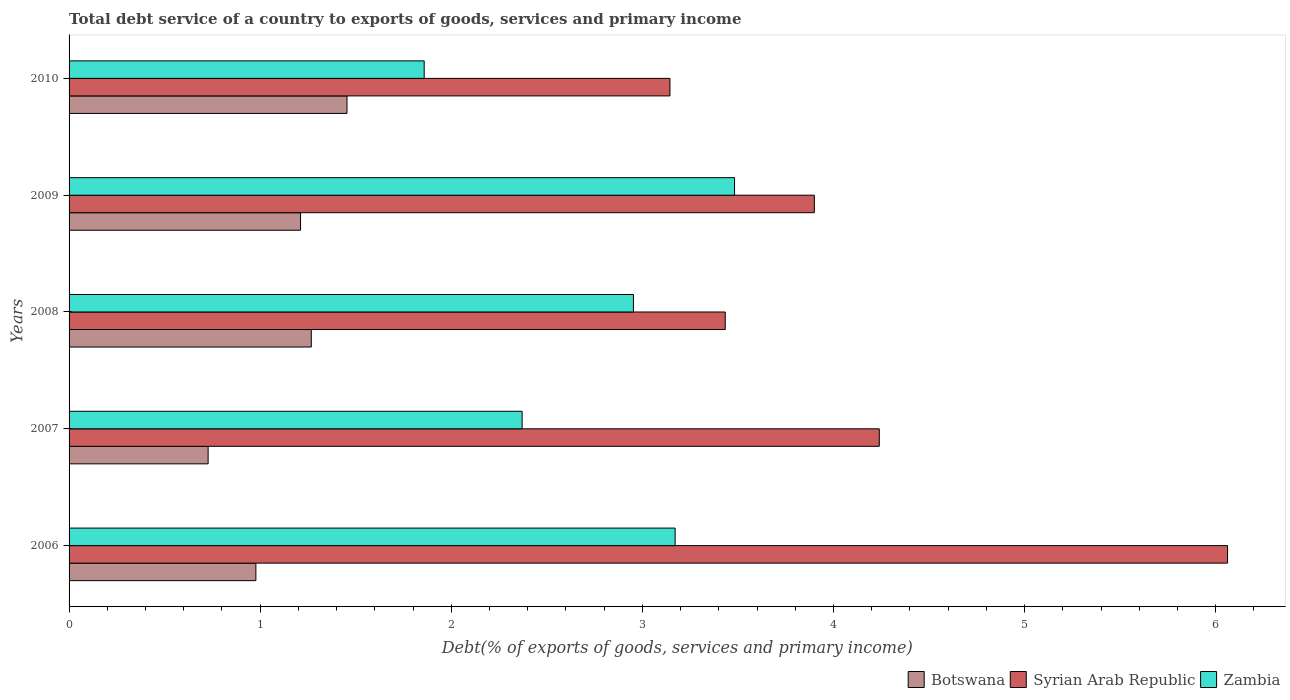How many groups of bars are there?
Your answer should be compact. 5. How many bars are there on the 3rd tick from the top?
Provide a succinct answer. 3. What is the label of the 4th group of bars from the top?
Ensure brevity in your answer.  2007. In how many cases, is the number of bars for a given year not equal to the number of legend labels?
Keep it short and to the point. 0. What is the total debt service in Zambia in 2006?
Make the answer very short. 3.17. Across all years, what is the maximum total debt service in Syrian Arab Republic?
Your answer should be very brief. 6.06. Across all years, what is the minimum total debt service in Botswana?
Keep it short and to the point. 0.73. In which year was the total debt service in Botswana maximum?
Give a very brief answer. 2010. What is the total total debt service in Zambia in the graph?
Provide a short and direct response. 13.84. What is the difference between the total debt service in Syrian Arab Republic in 2009 and that in 2010?
Offer a terse response. 0.76. What is the difference between the total debt service in Botswana in 2010 and the total debt service in Zambia in 2008?
Ensure brevity in your answer.  -1.5. What is the average total debt service in Botswana per year?
Your answer should be very brief. 1.13. In the year 2008, what is the difference between the total debt service in Syrian Arab Republic and total debt service in Zambia?
Make the answer very short. 0.48. What is the ratio of the total debt service in Syrian Arab Republic in 2008 to that in 2010?
Your response must be concise. 1.09. What is the difference between the highest and the second highest total debt service in Botswana?
Keep it short and to the point. 0.19. What is the difference between the highest and the lowest total debt service in Syrian Arab Republic?
Your response must be concise. 2.92. Is the sum of the total debt service in Syrian Arab Republic in 2008 and 2009 greater than the maximum total debt service in Zambia across all years?
Keep it short and to the point. Yes. What does the 3rd bar from the top in 2010 represents?
Your answer should be compact. Botswana. What does the 3rd bar from the bottom in 2008 represents?
Give a very brief answer. Zambia. How many bars are there?
Give a very brief answer. 15. How many years are there in the graph?
Provide a succinct answer. 5. Does the graph contain any zero values?
Provide a succinct answer. No. Where does the legend appear in the graph?
Make the answer very short. Bottom right. How are the legend labels stacked?
Make the answer very short. Horizontal. What is the title of the graph?
Provide a succinct answer. Total debt service of a country to exports of goods, services and primary income. What is the label or title of the X-axis?
Provide a short and direct response. Debt(% of exports of goods, services and primary income). What is the label or title of the Y-axis?
Ensure brevity in your answer.  Years. What is the Debt(% of exports of goods, services and primary income) of Botswana in 2006?
Keep it short and to the point. 0.98. What is the Debt(% of exports of goods, services and primary income) of Syrian Arab Republic in 2006?
Make the answer very short. 6.06. What is the Debt(% of exports of goods, services and primary income) of Zambia in 2006?
Provide a succinct answer. 3.17. What is the Debt(% of exports of goods, services and primary income) in Botswana in 2007?
Provide a short and direct response. 0.73. What is the Debt(% of exports of goods, services and primary income) in Syrian Arab Republic in 2007?
Your answer should be very brief. 4.24. What is the Debt(% of exports of goods, services and primary income) of Zambia in 2007?
Ensure brevity in your answer.  2.37. What is the Debt(% of exports of goods, services and primary income) in Botswana in 2008?
Offer a very short reply. 1.27. What is the Debt(% of exports of goods, services and primary income) in Syrian Arab Republic in 2008?
Provide a short and direct response. 3.43. What is the Debt(% of exports of goods, services and primary income) in Zambia in 2008?
Your response must be concise. 2.95. What is the Debt(% of exports of goods, services and primary income) of Botswana in 2009?
Your response must be concise. 1.21. What is the Debt(% of exports of goods, services and primary income) in Syrian Arab Republic in 2009?
Give a very brief answer. 3.9. What is the Debt(% of exports of goods, services and primary income) of Zambia in 2009?
Keep it short and to the point. 3.48. What is the Debt(% of exports of goods, services and primary income) of Botswana in 2010?
Your answer should be compact. 1.45. What is the Debt(% of exports of goods, services and primary income) in Syrian Arab Republic in 2010?
Provide a succinct answer. 3.14. What is the Debt(% of exports of goods, services and primary income) of Zambia in 2010?
Provide a short and direct response. 1.86. Across all years, what is the maximum Debt(% of exports of goods, services and primary income) of Botswana?
Your response must be concise. 1.45. Across all years, what is the maximum Debt(% of exports of goods, services and primary income) in Syrian Arab Republic?
Give a very brief answer. 6.06. Across all years, what is the maximum Debt(% of exports of goods, services and primary income) of Zambia?
Offer a very short reply. 3.48. Across all years, what is the minimum Debt(% of exports of goods, services and primary income) of Botswana?
Provide a succinct answer. 0.73. Across all years, what is the minimum Debt(% of exports of goods, services and primary income) of Syrian Arab Republic?
Provide a short and direct response. 3.14. Across all years, what is the minimum Debt(% of exports of goods, services and primary income) of Zambia?
Provide a succinct answer. 1.86. What is the total Debt(% of exports of goods, services and primary income) of Botswana in the graph?
Keep it short and to the point. 5.64. What is the total Debt(% of exports of goods, services and primary income) of Syrian Arab Republic in the graph?
Your answer should be very brief. 20.78. What is the total Debt(% of exports of goods, services and primary income) in Zambia in the graph?
Offer a terse response. 13.84. What is the difference between the Debt(% of exports of goods, services and primary income) of Botswana in 2006 and that in 2007?
Provide a short and direct response. 0.25. What is the difference between the Debt(% of exports of goods, services and primary income) of Syrian Arab Republic in 2006 and that in 2007?
Offer a very short reply. 1.82. What is the difference between the Debt(% of exports of goods, services and primary income) of Zambia in 2006 and that in 2007?
Your response must be concise. 0.8. What is the difference between the Debt(% of exports of goods, services and primary income) in Botswana in 2006 and that in 2008?
Offer a terse response. -0.29. What is the difference between the Debt(% of exports of goods, services and primary income) of Syrian Arab Republic in 2006 and that in 2008?
Give a very brief answer. 2.63. What is the difference between the Debt(% of exports of goods, services and primary income) of Zambia in 2006 and that in 2008?
Keep it short and to the point. 0.22. What is the difference between the Debt(% of exports of goods, services and primary income) in Botswana in 2006 and that in 2009?
Provide a succinct answer. -0.23. What is the difference between the Debt(% of exports of goods, services and primary income) of Syrian Arab Republic in 2006 and that in 2009?
Offer a very short reply. 2.16. What is the difference between the Debt(% of exports of goods, services and primary income) of Zambia in 2006 and that in 2009?
Provide a succinct answer. -0.31. What is the difference between the Debt(% of exports of goods, services and primary income) in Botswana in 2006 and that in 2010?
Make the answer very short. -0.48. What is the difference between the Debt(% of exports of goods, services and primary income) of Syrian Arab Republic in 2006 and that in 2010?
Make the answer very short. 2.92. What is the difference between the Debt(% of exports of goods, services and primary income) of Zambia in 2006 and that in 2010?
Make the answer very short. 1.31. What is the difference between the Debt(% of exports of goods, services and primary income) of Botswana in 2007 and that in 2008?
Give a very brief answer. -0.54. What is the difference between the Debt(% of exports of goods, services and primary income) in Syrian Arab Republic in 2007 and that in 2008?
Offer a terse response. 0.81. What is the difference between the Debt(% of exports of goods, services and primary income) of Zambia in 2007 and that in 2008?
Keep it short and to the point. -0.58. What is the difference between the Debt(% of exports of goods, services and primary income) in Botswana in 2007 and that in 2009?
Your response must be concise. -0.48. What is the difference between the Debt(% of exports of goods, services and primary income) of Syrian Arab Republic in 2007 and that in 2009?
Provide a short and direct response. 0.34. What is the difference between the Debt(% of exports of goods, services and primary income) in Zambia in 2007 and that in 2009?
Give a very brief answer. -1.11. What is the difference between the Debt(% of exports of goods, services and primary income) in Botswana in 2007 and that in 2010?
Provide a short and direct response. -0.73. What is the difference between the Debt(% of exports of goods, services and primary income) in Syrian Arab Republic in 2007 and that in 2010?
Make the answer very short. 1.1. What is the difference between the Debt(% of exports of goods, services and primary income) in Zambia in 2007 and that in 2010?
Your response must be concise. 0.51. What is the difference between the Debt(% of exports of goods, services and primary income) in Botswana in 2008 and that in 2009?
Provide a short and direct response. 0.06. What is the difference between the Debt(% of exports of goods, services and primary income) in Syrian Arab Republic in 2008 and that in 2009?
Make the answer very short. -0.47. What is the difference between the Debt(% of exports of goods, services and primary income) in Zambia in 2008 and that in 2009?
Provide a short and direct response. -0.53. What is the difference between the Debt(% of exports of goods, services and primary income) in Botswana in 2008 and that in 2010?
Provide a succinct answer. -0.19. What is the difference between the Debt(% of exports of goods, services and primary income) in Syrian Arab Republic in 2008 and that in 2010?
Offer a terse response. 0.29. What is the difference between the Debt(% of exports of goods, services and primary income) in Zambia in 2008 and that in 2010?
Provide a short and direct response. 1.09. What is the difference between the Debt(% of exports of goods, services and primary income) of Botswana in 2009 and that in 2010?
Ensure brevity in your answer.  -0.24. What is the difference between the Debt(% of exports of goods, services and primary income) in Syrian Arab Republic in 2009 and that in 2010?
Keep it short and to the point. 0.76. What is the difference between the Debt(% of exports of goods, services and primary income) of Zambia in 2009 and that in 2010?
Your answer should be very brief. 1.62. What is the difference between the Debt(% of exports of goods, services and primary income) of Botswana in 2006 and the Debt(% of exports of goods, services and primary income) of Syrian Arab Republic in 2007?
Make the answer very short. -3.26. What is the difference between the Debt(% of exports of goods, services and primary income) in Botswana in 2006 and the Debt(% of exports of goods, services and primary income) in Zambia in 2007?
Offer a terse response. -1.39. What is the difference between the Debt(% of exports of goods, services and primary income) in Syrian Arab Republic in 2006 and the Debt(% of exports of goods, services and primary income) in Zambia in 2007?
Your answer should be compact. 3.69. What is the difference between the Debt(% of exports of goods, services and primary income) in Botswana in 2006 and the Debt(% of exports of goods, services and primary income) in Syrian Arab Republic in 2008?
Provide a short and direct response. -2.46. What is the difference between the Debt(% of exports of goods, services and primary income) in Botswana in 2006 and the Debt(% of exports of goods, services and primary income) in Zambia in 2008?
Make the answer very short. -1.98. What is the difference between the Debt(% of exports of goods, services and primary income) in Syrian Arab Republic in 2006 and the Debt(% of exports of goods, services and primary income) in Zambia in 2008?
Provide a succinct answer. 3.11. What is the difference between the Debt(% of exports of goods, services and primary income) in Botswana in 2006 and the Debt(% of exports of goods, services and primary income) in Syrian Arab Republic in 2009?
Your answer should be compact. -2.92. What is the difference between the Debt(% of exports of goods, services and primary income) in Botswana in 2006 and the Debt(% of exports of goods, services and primary income) in Zambia in 2009?
Provide a short and direct response. -2.5. What is the difference between the Debt(% of exports of goods, services and primary income) in Syrian Arab Republic in 2006 and the Debt(% of exports of goods, services and primary income) in Zambia in 2009?
Make the answer very short. 2.58. What is the difference between the Debt(% of exports of goods, services and primary income) of Botswana in 2006 and the Debt(% of exports of goods, services and primary income) of Syrian Arab Republic in 2010?
Your response must be concise. -2.17. What is the difference between the Debt(% of exports of goods, services and primary income) of Botswana in 2006 and the Debt(% of exports of goods, services and primary income) of Zambia in 2010?
Provide a short and direct response. -0.88. What is the difference between the Debt(% of exports of goods, services and primary income) in Syrian Arab Republic in 2006 and the Debt(% of exports of goods, services and primary income) in Zambia in 2010?
Your response must be concise. 4.2. What is the difference between the Debt(% of exports of goods, services and primary income) in Botswana in 2007 and the Debt(% of exports of goods, services and primary income) in Syrian Arab Republic in 2008?
Offer a very short reply. -2.71. What is the difference between the Debt(% of exports of goods, services and primary income) of Botswana in 2007 and the Debt(% of exports of goods, services and primary income) of Zambia in 2008?
Keep it short and to the point. -2.23. What is the difference between the Debt(% of exports of goods, services and primary income) in Syrian Arab Republic in 2007 and the Debt(% of exports of goods, services and primary income) in Zambia in 2008?
Make the answer very short. 1.29. What is the difference between the Debt(% of exports of goods, services and primary income) in Botswana in 2007 and the Debt(% of exports of goods, services and primary income) in Syrian Arab Republic in 2009?
Offer a very short reply. -3.17. What is the difference between the Debt(% of exports of goods, services and primary income) of Botswana in 2007 and the Debt(% of exports of goods, services and primary income) of Zambia in 2009?
Make the answer very short. -2.75. What is the difference between the Debt(% of exports of goods, services and primary income) in Syrian Arab Republic in 2007 and the Debt(% of exports of goods, services and primary income) in Zambia in 2009?
Provide a short and direct response. 0.76. What is the difference between the Debt(% of exports of goods, services and primary income) in Botswana in 2007 and the Debt(% of exports of goods, services and primary income) in Syrian Arab Republic in 2010?
Ensure brevity in your answer.  -2.42. What is the difference between the Debt(% of exports of goods, services and primary income) of Botswana in 2007 and the Debt(% of exports of goods, services and primary income) of Zambia in 2010?
Provide a short and direct response. -1.13. What is the difference between the Debt(% of exports of goods, services and primary income) of Syrian Arab Republic in 2007 and the Debt(% of exports of goods, services and primary income) of Zambia in 2010?
Provide a short and direct response. 2.38. What is the difference between the Debt(% of exports of goods, services and primary income) of Botswana in 2008 and the Debt(% of exports of goods, services and primary income) of Syrian Arab Republic in 2009?
Your answer should be very brief. -2.63. What is the difference between the Debt(% of exports of goods, services and primary income) of Botswana in 2008 and the Debt(% of exports of goods, services and primary income) of Zambia in 2009?
Provide a succinct answer. -2.21. What is the difference between the Debt(% of exports of goods, services and primary income) of Syrian Arab Republic in 2008 and the Debt(% of exports of goods, services and primary income) of Zambia in 2009?
Your answer should be compact. -0.05. What is the difference between the Debt(% of exports of goods, services and primary income) in Botswana in 2008 and the Debt(% of exports of goods, services and primary income) in Syrian Arab Republic in 2010?
Offer a terse response. -1.88. What is the difference between the Debt(% of exports of goods, services and primary income) of Botswana in 2008 and the Debt(% of exports of goods, services and primary income) of Zambia in 2010?
Your response must be concise. -0.59. What is the difference between the Debt(% of exports of goods, services and primary income) of Syrian Arab Republic in 2008 and the Debt(% of exports of goods, services and primary income) of Zambia in 2010?
Keep it short and to the point. 1.58. What is the difference between the Debt(% of exports of goods, services and primary income) of Botswana in 2009 and the Debt(% of exports of goods, services and primary income) of Syrian Arab Republic in 2010?
Make the answer very short. -1.93. What is the difference between the Debt(% of exports of goods, services and primary income) in Botswana in 2009 and the Debt(% of exports of goods, services and primary income) in Zambia in 2010?
Offer a very short reply. -0.65. What is the difference between the Debt(% of exports of goods, services and primary income) of Syrian Arab Republic in 2009 and the Debt(% of exports of goods, services and primary income) of Zambia in 2010?
Offer a terse response. 2.04. What is the average Debt(% of exports of goods, services and primary income) of Botswana per year?
Ensure brevity in your answer.  1.13. What is the average Debt(% of exports of goods, services and primary income) of Syrian Arab Republic per year?
Your answer should be very brief. 4.16. What is the average Debt(% of exports of goods, services and primary income) in Zambia per year?
Offer a terse response. 2.77. In the year 2006, what is the difference between the Debt(% of exports of goods, services and primary income) of Botswana and Debt(% of exports of goods, services and primary income) of Syrian Arab Republic?
Make the answer very short. -5.08. In the year 2006, what is the difference between the Debt(% of exports of goods, services and primary income) of Botswana and Debt(% of exports of goods, services and primary income) of Zambia?
Provide a short and direct response. -2.19. In the year 2006, what is the difference between the Debt(% of exports of goods, services and primary income) of Syrian Arab Republic and Debt(% of exports of goods, services and primary income) of Zambia?
Your answer should be very brief. 2.89. In the year 2007, what is the difference between the Debt(% of exports of goods, services and primary income) of Botswana and Debt(% of exports of goods, services and primary income) of Syrian Arab Republic?
Your answer should be very brief. -3.51. In the year 2007, what is the difference between the Debt(% of exports of goods, services and primary income) in Botswana and Debt(% of exports of goods, services and primary income) in Zambia?
Your answer should be very brief. -1.64. In the year 2007, what is the difference between the Debt(% of exports of goods, services and primary income) of Syrian Arab Republic and Debt(% of exports of goods, services and primary income) of Zambia?
Give a very brief answer. 1.87. In the year 2008, what is the difference between the Debt(% of exports of goods, services and primary income) in Botswana and Debt(% of exports of goods, services and primary income) in Syrian Arab Republic?
Your answer should be very brief. -2.17. In the year 2008, what is the difference between the Debt(% of exports of goods, services and primary income) in Botswana and Debt(% of exports of goods, services and primary income) in Zambia?
Your answer should be very brief. -1.69. In the year 2008, what is the difference between the Debt(% of exports of goods, services and primary income) in Syrian Arab Republic and Debt(% of exports of goods, services and primary income) in Zambia?
Keep it short and to the point. 0.48. In the year 2009, what is the difference between the Debt(% of exports of goods, services and primary income) in Botswana and Debt(% of exports of goods, services and primary income) in Syrian Arab Republic?
Your answer should be very brief. -2.69. In the year 2009, what is the difference between the Debt(% of exports of goods, services and primary income) of Botswana and Debt(% of exports of goods, services and primary income) of Zambia?
Provide a short and direct response. -2.27. In the year 2009, what is the difference between the Debt(% of exports of goods, services and primary income) of Syrian Arab Republic and Debt(% of exports of goods, services and primary income) of Zambia?
Keep it short and to the point. 0.42. In the year 2010, what is the difference between the Debt(% of exports of goods, services and primary income) in Botswana and Debt(% of exports of goods, services and primary income) in Syrian Arab Republic?
Offer a terse response. -1.69. In the year 2010, what is the difference between the Debt(% of exports of goods, services and primary income) of Botswana and Debt(% of exports of goods, services and primary income) of Zambia?
Your answer should be very brief. -0.4. In the year 2010, what is the difference between the Debt(% of exports of goods, services and primary income) of Syrian Arab Republic and Debt(% of exports of goods, services and primary income) of Zambia?
Ensure brevity in your answer.  1.29. What is the ratio of the Debt(% of exports of goods, services and primary income) in Botswana in 2006 to that in 2007?
Provide a short and direct response. 1.34. What is the ratio of the Debt(% of exports of goods, services and primary income) in Syrian Arab Republic in 2006 to that in 2007?
Provide a short and direct response. 1.43. What is the ratio of the Debt(% of exports of goods, services and primary income) of Zambia in 2006 to that in 2007?
Make the answer very short. 1.34. What is the ratio of the Debt(% of exports of goods, services and primary income) of Botswana in 2006 to that in 2008?
Provide a short and direct response. 0.77. What is the ratio of the Debt(% of exports of goods, services and primary income) in Syrian Arab Republic in 2006 to that in 2008?
Keep it short and to the point. 1.77. What is the ratio of the Debt(% of exports of goods, services and primary income) of Zambia in 2006 to that in 2008?
Offer a very short reply. 1.07. What is the ratio of the Debt(% of exports of goods, services and primary income) in Botswana in 2006 to that in 2009?
Your answer should be very brief. 0.81. What is the ratio of the Debt(% of exports of goods, services and primary income) of Syrian Arab Republic in 2006 to that in 2009?
Your answer should be very brief. 1.55. What is the ratio of the Debt(% of exports of goods, services and primary income) in Zambia in 2006 to that in 2009?
Keep it short and to the point. 0.91. What is the ratio of the Debt(% of exports of goods, services and primary income) of Botswana in 2006 to that in 2010?
Offer a very short reply. 0.67. What is the ratio of the Debt(% of exports of goods, services and primary income) in Syrian Arab Republic in 2006 to that in 2010?
Provide a short and direct response. 1.93. What is the ratio of the Debt(% of exports of goods, services and primary income) in Zambia in 2006 to that in 2010?
Ensure brevity in your answer.  1.71. What is the ratio of the Debt(% of exports of goods, services and primary income) of Botswana in 2007 to that in 2008?
Your answer should be compact. 0.57. What is the ratio of the Debt(% of exports of goods, services and primary income) of Syrian Arab Republic in 2007 to that in 2008?
Offer a terse response. 1.23. What is the ratio of the Debt(% of exports of goods, services and primary income) of Zambia in 2007 to that in 2008?
Provide a short and direct response. 0.8. What is the ratio of the Debt(% of exports of goods, services and primary income) of Botswana in 2007 to that in 2009?
Provide a short and direct response. 0.6. What is the ratio of the Debt(% of exports of goods, services and primary income) of Syrian Arab Republic in 2007 to that in 2009?
Keep it short and to the point. 1.09. What is the ratio of the Debt(% of exports of goods, services and primary income) of Zambia in 2007 to that in 2009?
Offer a terse response. 0.68. What is the ratio of the Debt(% of exports of goods, services and primary income) in Botswana in 2007 to that in 2010?
Your answer should be very brief. 0.5. What is the ratio of the Debt(% of exports of goods, services and primary income) in Syrian Arab Republic in 2007 to that in 2010?
Offer a very short reply. 1.35. What is the ratio of the Debt(% of exports of goods, services and primary income) of Zambia in 2007 to that in 2010?
Provide a short and direct response. 1.28. What is the ratio of the Debt(% of exports of goods, services and primary income) of Botswana in 2008 to that in 2009?
Keep it short and to the point. 1.05. What is the ratio of the Debt(% of exports of goods, services and primary income) of Syrian Arab Republic in 2008 to that in 2009?
Your answer should be compact. 0.88. What is the ratio of the Debt(% of exports of goods, services and primary income) of Zambia in 2008 to that in 2009?
Your answer should be compact. 0.85. What is the ratio of the Debt(% of exports of goods, services and primary income) in Botswana in 2008 to that in 2010?
Ensure brevity in your answer.  0.87. What is the ratio of the Debt(% of exports of goods, services and primary income) in Syrian Arab Republic in 2008 to that in 2010?
Give a very brief answer. 1.09. What is the ratio of the Debt(% of exports of goods, services and primary income) in Zambia in 2008 to that in 2010?
Your answer should be compact. 1.59. What is the ratio of the Debt(% of exports of goods, services and primary income) of Botswana in 2009 to that in 2010?
Your response must be concise. 0.83. What is the ratio of the Debt(% of exports of goods, services and primary income) of Syrian Arab Republic in 2009 to that in 2010?
Offer a very short reply. 1.24. What is the ratio of the Debt(% of exports of goods, services and primary income) in Zambia in 2009 to that in 2010?
Your answer should be very brief. 1.87. What is the difference between the highest and the second highest Debt(% of exports of goods, services and primary income) in Botswana?
Your response must be concise. 0.19. What is the difference between the highest and the second highest Debt(% of exports of goods, services and primary income) of Syrian Arab Republic?
Offer a very short reply. 1.82. What is the difference between the highest and the second highest Debt(% of exports of goods, services and primary income) in Zambia?
Provide a succinct answer. 0.31. What is the difference between the highest and the lowest Debt(% of exports of goods, services and primary income) of Botswana?
Offer a very short reply. 0.73. What is the difference between the highest and the lowest Debt(% of exports of goods, services and primary income) of Syrian Arab Republic?
Your answer should be compact. 2.92. What is the difference between the highest and the lowest Debt(% of exports of goods, services and primary income) in Zambia?
Ensure brevity in your answer.  1.62. 